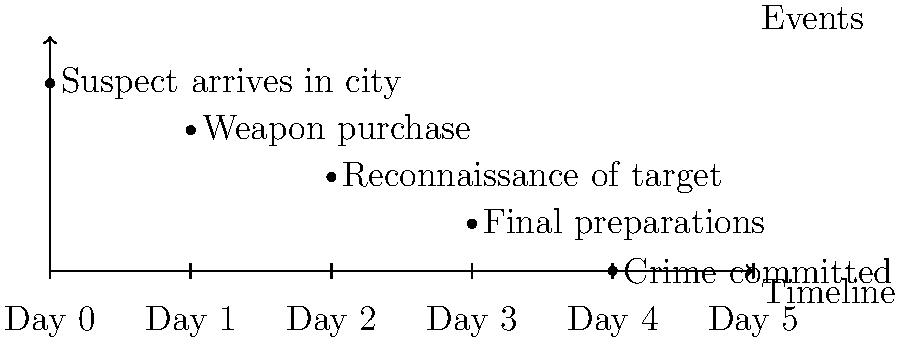Based on the timeline diagram of events leading up to a high-profile crime, how many days elapsed between the suspect's arrival in the city and the execution of the crime? To determine the number of days between the suspect's arrival and the crime, we need to analyze the timeline:

1. Day 0: Suspect arrives in the city
2. Day 1: Weapon purchase
3. Day 2: Reconnaissance of target
4. Day 3: Final preparations
5. Day 4: Crime committed

The timeline shows a progression of events over 5 days (Days 0-4). 

Step 1: Identify the start date
The suspect arrives on Day 0.

Step 2: Identify the end date
The crime is committed on Day 4.

Step 3: Calculate the elapsed time
To find the elapsed time, we subtract the start date from the end date:
$4 - 0 = 4$

Therefore, 4 days elapsed between the suspect's arrival and the crime.
Answer: 4 days 